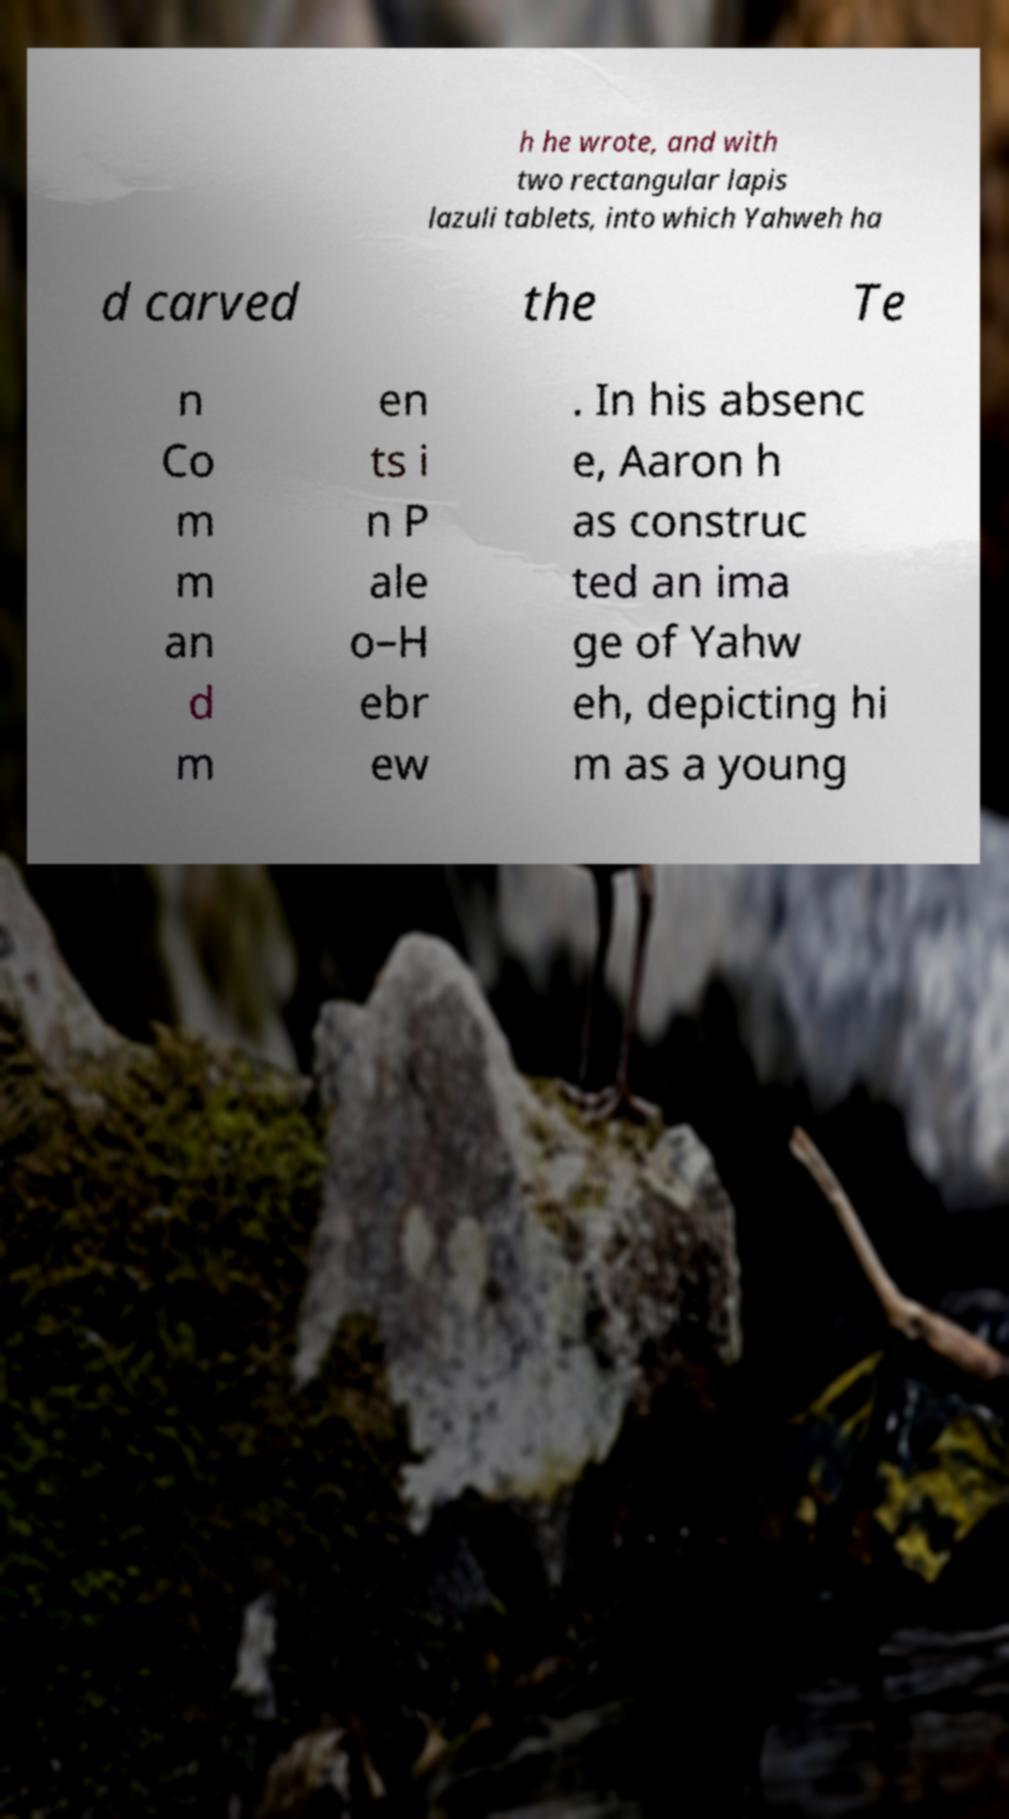Please read and relay the text visible in this image. What does it say? h he wrote, and with two rectangular lapis lazuli tablets, into which Yahweh ha d carved the Te n Co m m an d m en ts i n P ale o–H ebr ew . In his absenc e, Aaron h as construc ted an ima ge of Yahw eh, depicting hi m as a young 